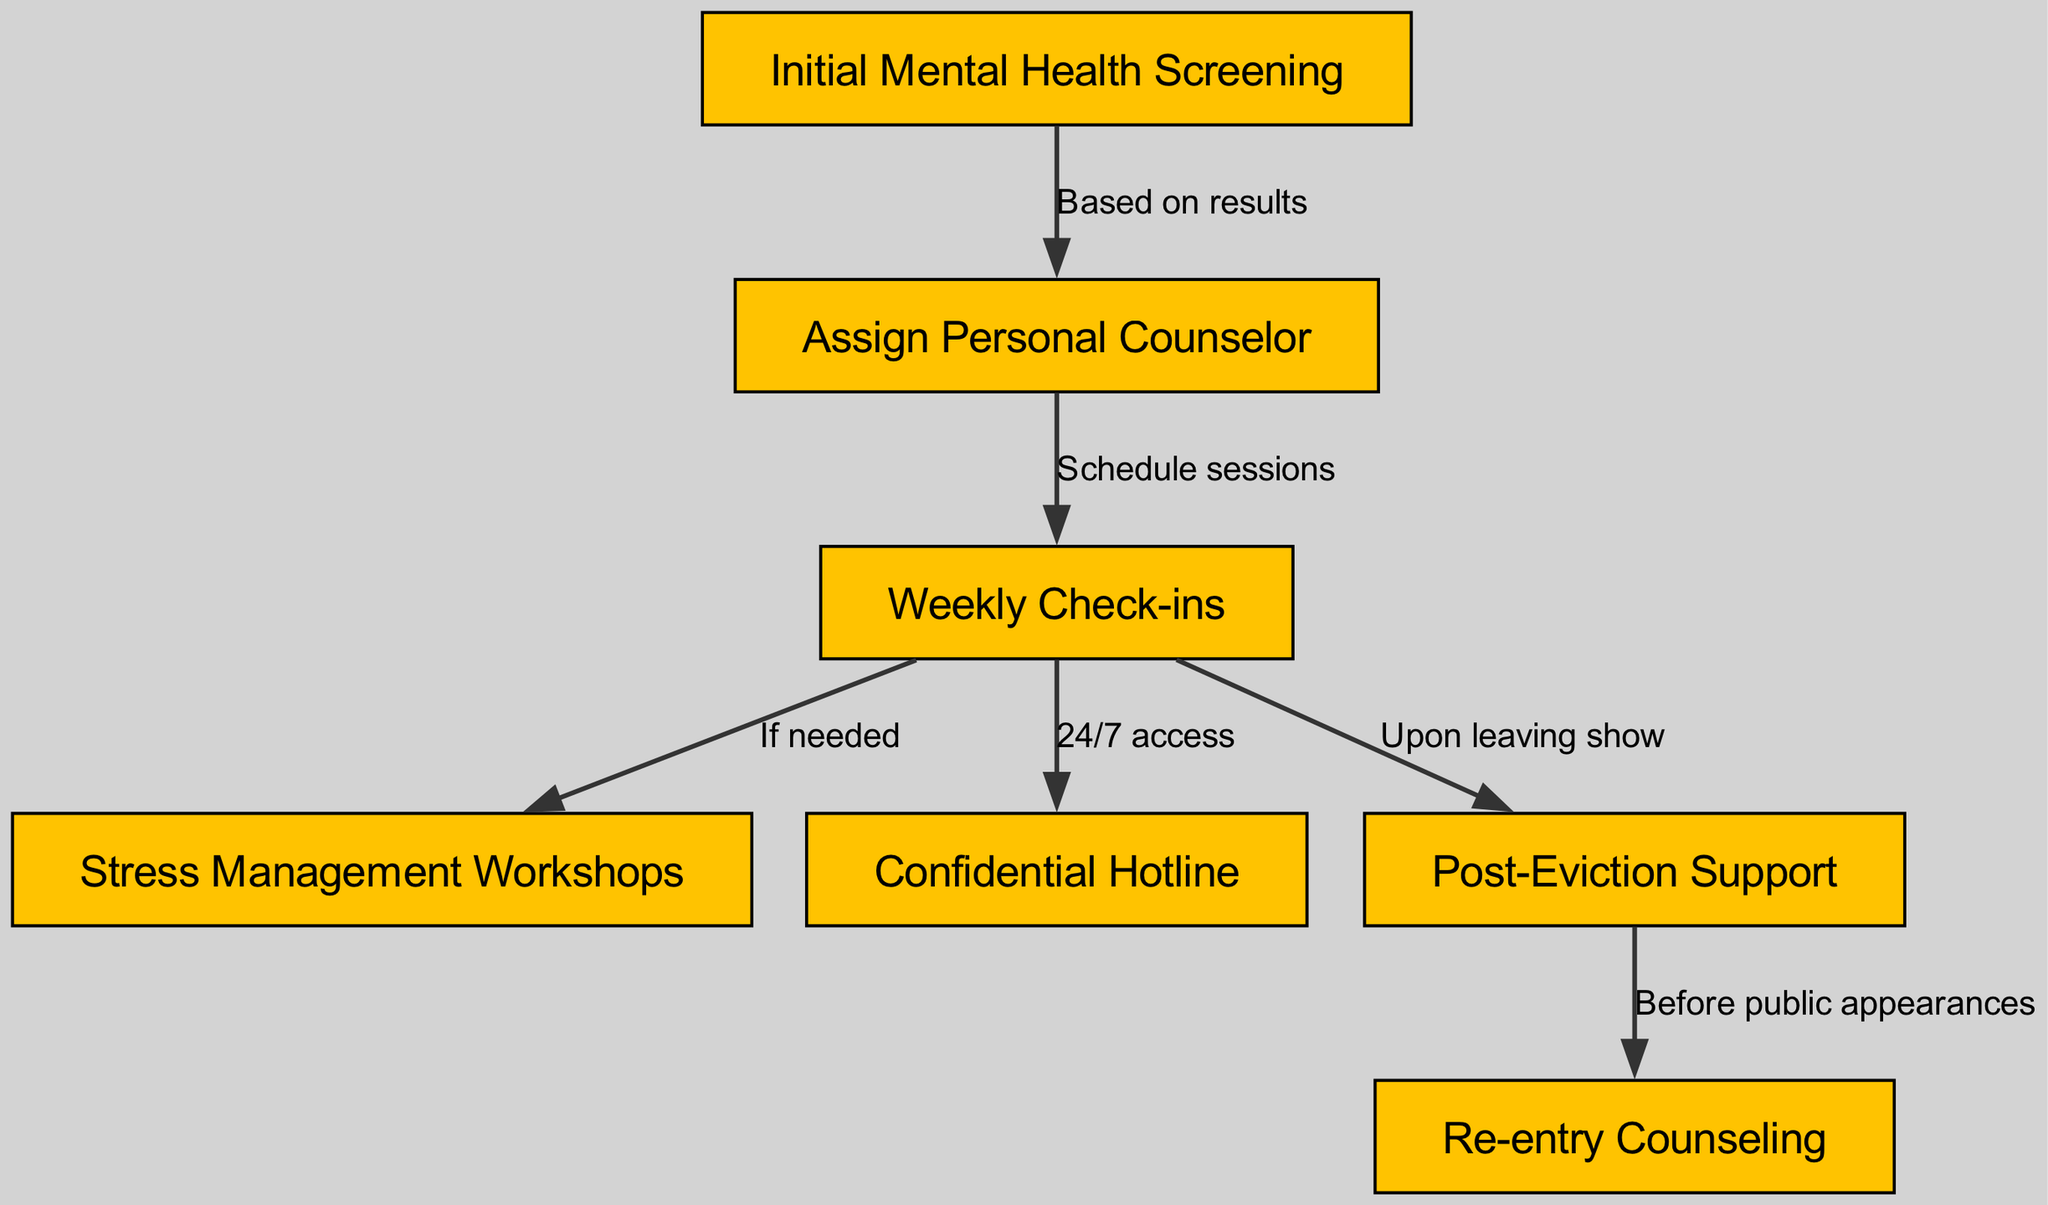What is the first step in the mental health support protocol? The diagram indicates the first node as "Initial Mental Health Screening," which is the starting point for addressing mental health concerns for participants.
Answer: Initial Mental Health Screening How many nodes are present in the diagram? By counting the nodes listed in the diagram data, there are a total of seven distinct nodes that represent different components of the support protocol.
Answer: 7 What is the relationship between "Weekly Check-ins" and "Stress Management Workshops"? The diagram shows a direct connection from "Weekly Check-ins" to "Stress Management Workshops," indicating that workshops are provided if needed based on the weekly evaluations.
Answer: If needed What services are accessible after "Weekly Check-ins"? The edges connected to "Weekly Check-ins" reveal three services: "Stress Management Workshops," "Confidential Hotline," and "Post-Eviction Support," suggesting that participants can access these services depending on their needs.
Answer: Stress Management Workshops, Confidential Hotline, Post-Eviction Support What happens after "Post-Eviction Support"? The diagram specifies that after "Post-Eviction Support," there is a connection to "Re-entry Counseling," indicating that support continues for participants even after leaving the show.
Answer: Re-entry Counseling How does “Initial Mental Health Screening” affect counseling assignment? The diagram indicates that the assignment of a “Personal Counselor” is based on the results from the "Initial Mental Health Screening," meaning the screening determines if a counselor is allocated to the participant.
Answer: Based on results What type of support is available 24/7? The diagram highlights the "Confidential Hotline" as an available service providing continuous support, suggesting that participants can reach out for help at any time.
Answer: Confidential Hotline When is “Re-entry Counseling” provided? According to the diagram, “Re-entry Counseling” is available before public appearances following the completion of "Post-Eviction Support," indicating a structured transition back into public life.
Answer: Before public appearances 